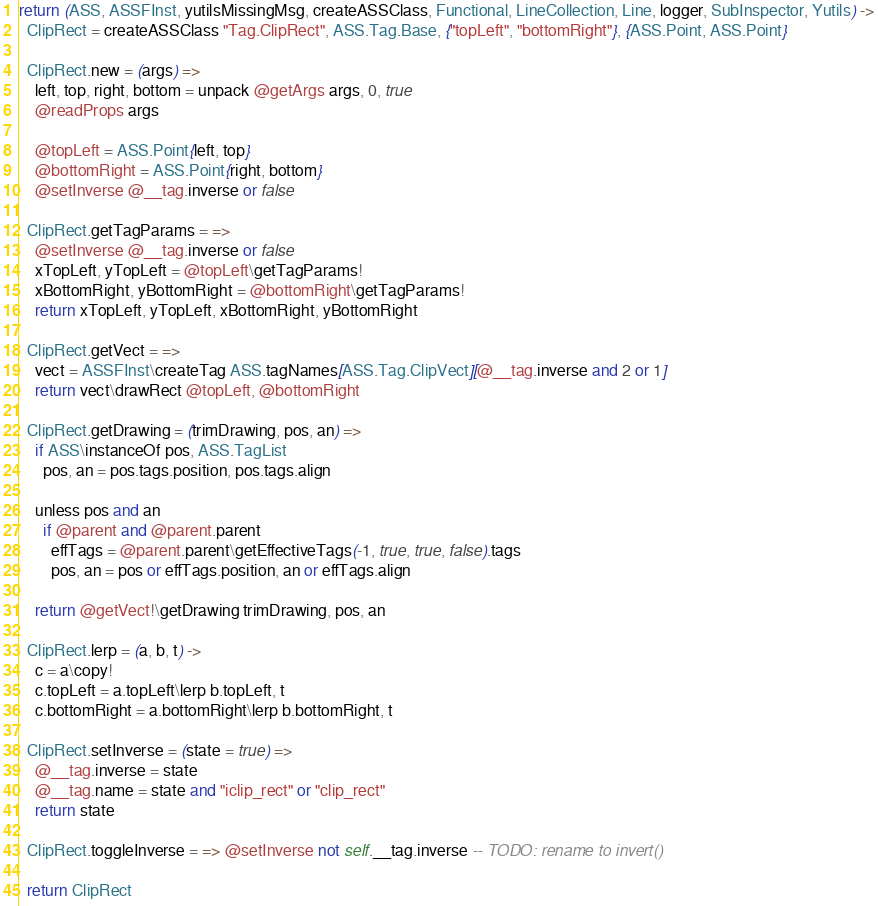Convert code to text. <code><loc_0><loc_0><loc_500><loc_500><_MoonScript_>return (ASS, ASSFInst, yutilsMissingMsg, createASSClass, Functional, LineCollection, Line, logger, SubInspector, Yutils) ->
  ClipRect = createASSClass "Tag.ClipRect", ASS.Tag.Base, {"topLeft", "bottomRight"}, {ASS.Point, ASS.Point}

  ClipRect.new = (args) =>
    left, top, right, bottom = unpack @getArgs args, 0, true
    @readProps args

    @topLeft = ASS.Point{left, top}
    @bottomRight = ASS.Point{right, bottom}
    @setInverse @__tag.inverse or false

  ClipRect.getTagParams = =>
    @setInverse @__tag.inverse or false
    xTopLeft, yTopLeft = @topLeft\getTagParams!
    xBottomRight, yBottomRight = @bottomRight\getTagParams!
    return xTopLeft, yTopLeft, xBottomRight, yBottomRight

  ClipRect.getVect = =>
    vect = ASSFInst\createTag ASS.tagNames[ASS.Tag.ClipVect][@__tag.inverse and 2 or 1]
    return vect\drawRect @topLeft, @bottomRight

  ClipRect.getDrawing = (trimDrawing, pos, an) =>
    if ASS\instanceOf pos, ASS.TagList
      pos, an = pos.tags.position, pos.tags.align

    unless pos and an
      if @parent and @parent.parent
        effTags = @parent.parent\getEffectiveTags(-1, true, true, false).tags
        pos, an = pos or effTags.position, an or effTags.align

    return @getVect!\getDrawing trimDrawing, pos, an

  ClipRect.lerp = (a, b, t) ->
    c = a\copy!
    c.topLeft = a.topLeft\lerp b.topLeft, t
    c.bottomRight = a.bottomRight\lerp b.bottomRight, t

  ClipRect.setInverse = (state = true) =>
    @__tag.inverse = state
    @__tag.name = state and "iclip_rect" or "clip_rect"
    return state

  ClipRect.toggleInverse = => @setInverse not self.__tag.inverse -- TODO: rename to invert()

  return ClipRect
</code> 